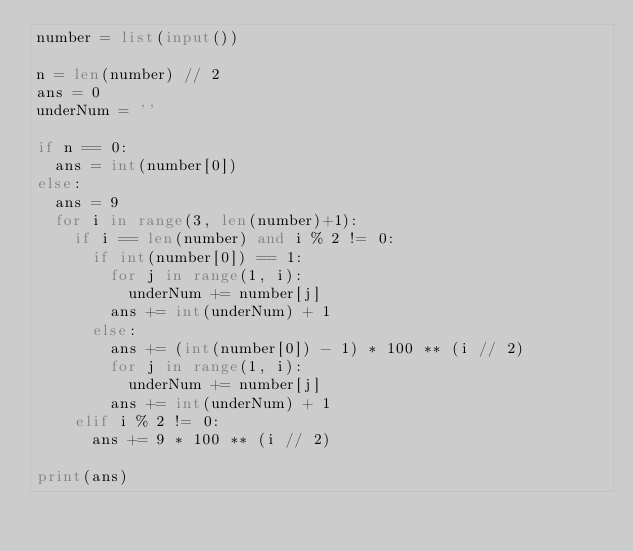Convert code to text. <code><loc_0><loc_0><loc_500><loc_500><_Python_>number = list(input())

n = len(number) // 2
ans = 0
underNum = ''

if n == 0:
  ans = int(number[0])
else:
  ans = 9
  for i in range(3, len(number)+1):
    if i == len(number) and i % 2 != 0:
      if int(number[0]) == 1:
        for j in range(1, i):
          underNum += number[j]
        ans += int(underNum) + 1
      else:
        ans += (int(number[0]) - 1) * 100 ** (i // 2)
        for j in range(1, i):
          underNum += number[j]
        ans += int(underNum) + 1
    elif i % 2 != 0:
      ans += 9 * 100 ** (i // 2)
      
print(ans)</code> 